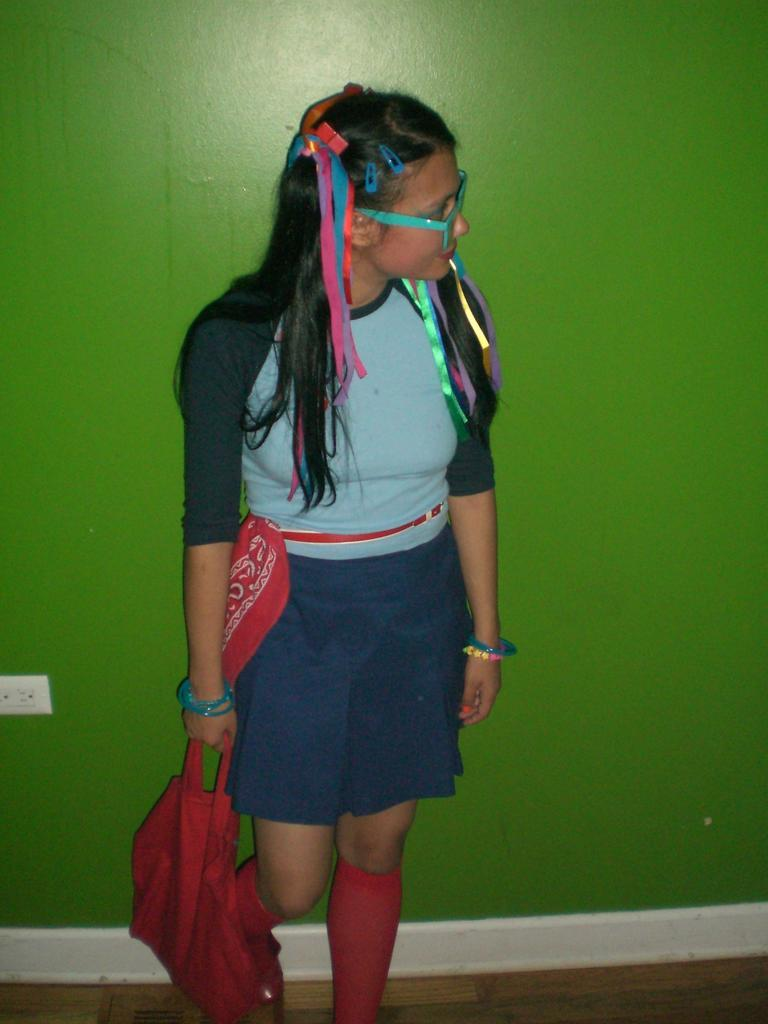Who is the main subject in the image? There is a woman in the center of the image. What is the woman doing in the image? The woman is standing on the floor. What is the woman holding in the image? The woman is holding a bag. What can be seen in the background of the image? There is a wall in the background of the image. What type of education is the woman receiving in the image? There is no indication in the image that the woman is receiving any education. How many tomatoes can be seen in the woman's hair in the image? There are no tomatoes present in the image, let alone in the woman's hair. 